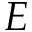<formula> <loc_0><loc_0><loc_500><loc_500>E</formula> 